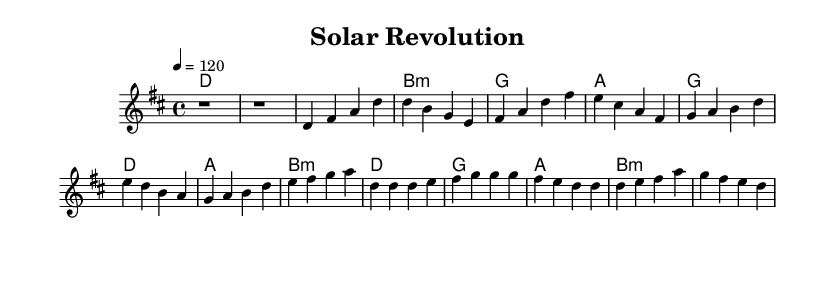What is the key signature of this music? The key signature is D major, indicated by the presence of two sharps (F# and C#) which can be seen at the beginning of the sheet music.
Answer: D major What is the time signature? The time signature is 4/4, represented at the start of the score. This means there are four beats per measure and the quarter note gets one beat.
Answer: 4/4 What is the tempo marking for this piece? The tempo marking is 120 beats per minute, as indicated by the '4 = 120' which shows the pace at which the music should be played.
Answer: 120 How many measures are in the chorus section? The chorus section contains four measures, which can be counted by identifying the measures that contain music notation after identifying the designated chorus section.
Answer: 4 What is the first chord in the introduction? The first chord in the introduction is D major, which is notated in the chord names section at the very beginning of the piece.
Answer: D What is the last note of the verse? The last note of the verse is E, which can be found at the end of the melody for the verse section before the pre-chorus begins.
Answer: E What are the primary chords used in the chorus? The primary chords used in the chorus are D, G, A, and B minor, which are all listed in the harmonies section corresponding to the melody of the chorus.
Answer: D, G, A, B minor 